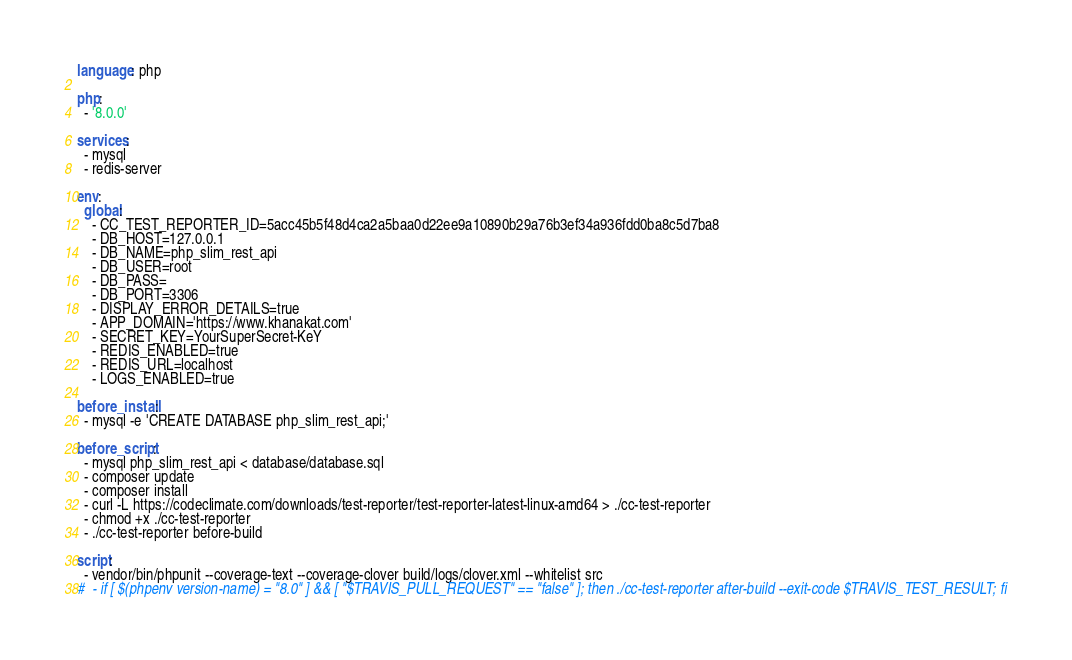<code> <loc_0><loc_0><loc_500><loc_500><_YAML_>language: php

php:
  - '8.0.0'

services:
  - mysql
  - redis-server

env:
  global:
    - CC_TEST_REPORTER_ID=5acc45b5f48d4ca2a5baa0d22ee9a10890b29a76b3ef34a936fdd0ba8c5d7ba8
    - DB_HOST=127.0.0.1
    - DB_NAME=php_slim_rest_api
    - DB_USER=root
    - DB_PASS=
    - DB_PORT=3306
    - DISPLAY_ERROR_DETAILS=true
    - APP_DOMAIN='https://www.khanakat.com'
    - SECRET_KEY=YourSuperSecret-KeY
    - REDIS_ENABLED=true
    - REDIS_URL=localhost
    - LOGS_ENABLED=true

before_install:
  - mysql -e 'CREATE DATABASE php_slim_rest_api;'

before_script:
  - mysql php_slim_rest_api < database/database.sql
  - composer update
  - composer install
  - curl -L https://codeclimate.com/downloads/test-reporter/test-reporter-latest-linux-amd64 > ./cc-test-reporter
  - chmod +x ./cc-test-reporter
  - ./cc-test-reporter before-build

script:
  - vendor/bin/phpunit --coverage-text --coverage-clover build/logs/clover.xml --whitelist src
#  - if [ $(phpenv version-name) = "8.0" ] && [ "$TRAVIS_PULL_REQUEST" == "false" ]; then ./cc-test-reporter after-build --exit-code $TRAVIS_TEST_RESULT; fi
</code> 